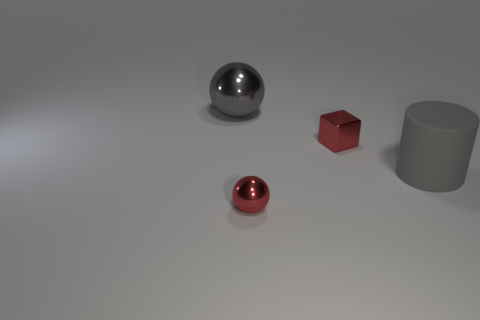Is the color of the tiny shiny cube the same as the tiny ball?
Your response must be concise. Yes. What number of other objects are the same size as the gray shiny sphere?
Give a very brief answer. 1. The rubber thing is what color?
Your response must be concise. Gray. What number of matte things are big gray objects or balls?
Provide a succinct answer. 1. Is there anything else that is made of the same material as the small red sphere?
Ensure brevity in your answer.  Yes. What is the size of the metal ball to the right of the shiny sphere that is behind the tiny metal thing that is left of the red metal block?
Provide a succinct answer. Small. What size is the object that is both on the left side of the metal cube and in front of the big gray shiny ball?
Keep it short and to the point. Small. Do the large thing on the left side of the red metal ball and the small shiny thing in front of the large cylinder have the same color?
Make the answer very short. No. There is a large gray metallic object; what number of big gray rubber cylinders are behind it?
Give a very brief answer. 0. Are there any big matte things that are behind the tiny thing that is to the right of the tiny metallic thing that is in front of the large gray cylinder?
Give a very brief answer. No. 